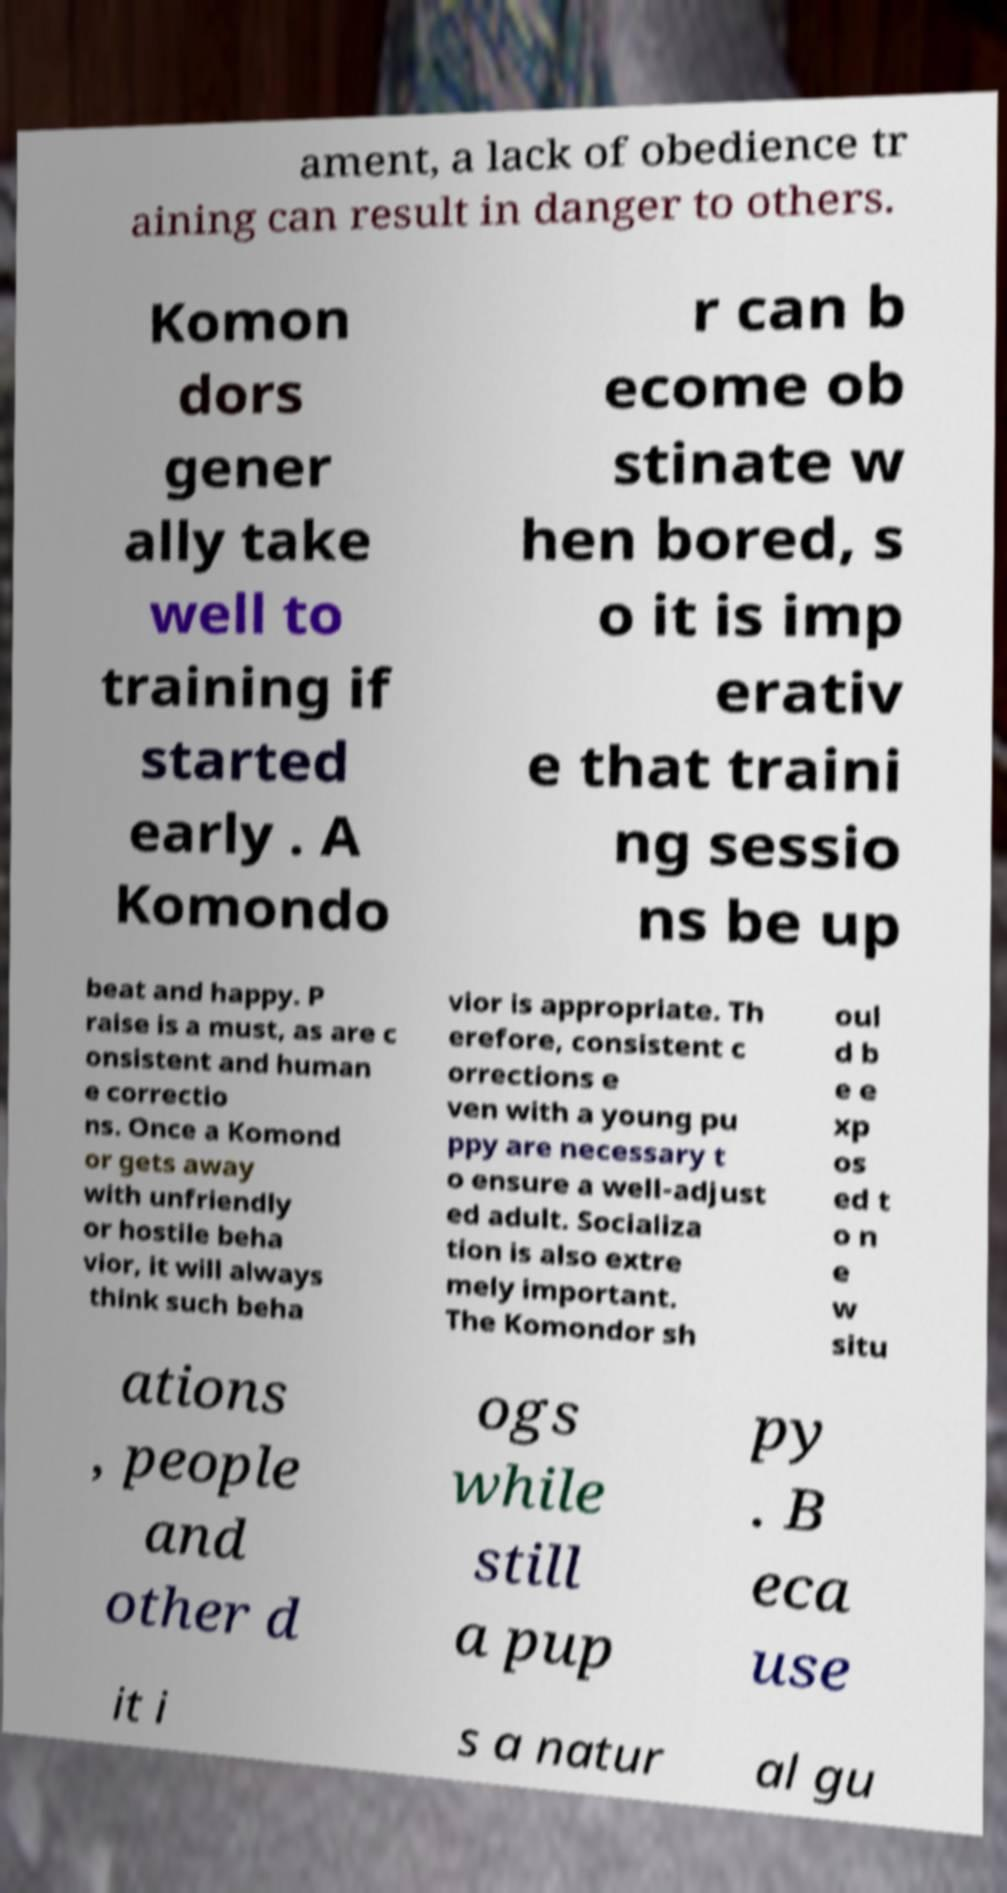There's text embedded in this image that I need extracted. Can you transcribe it verbatim? ament, a lack of obedience tr aining can result in danger to others. Komon dors gener ally take well to training if started early . A Komondo r can b ecome ob stinate w hen bored, s o it is imp erativ e that traini ng sessio ns be up beat and happy. P raise is a must, as are c onsistent and human e correctio ns. Once a Komond or gets away with unfriendly or hostile beha vior, it will always think such beha vior is appropriate. Th erefore, consistent c orrections e ven with a young pu ppy are necessary t o ensure a well-adjust ed adult. Socializa tion is also extre mely important. The Komondor sh oul d b e e xp os ed t o n e w situ ations , people and other d ogs while still a pup py . B eca use it i s a natur al gu 